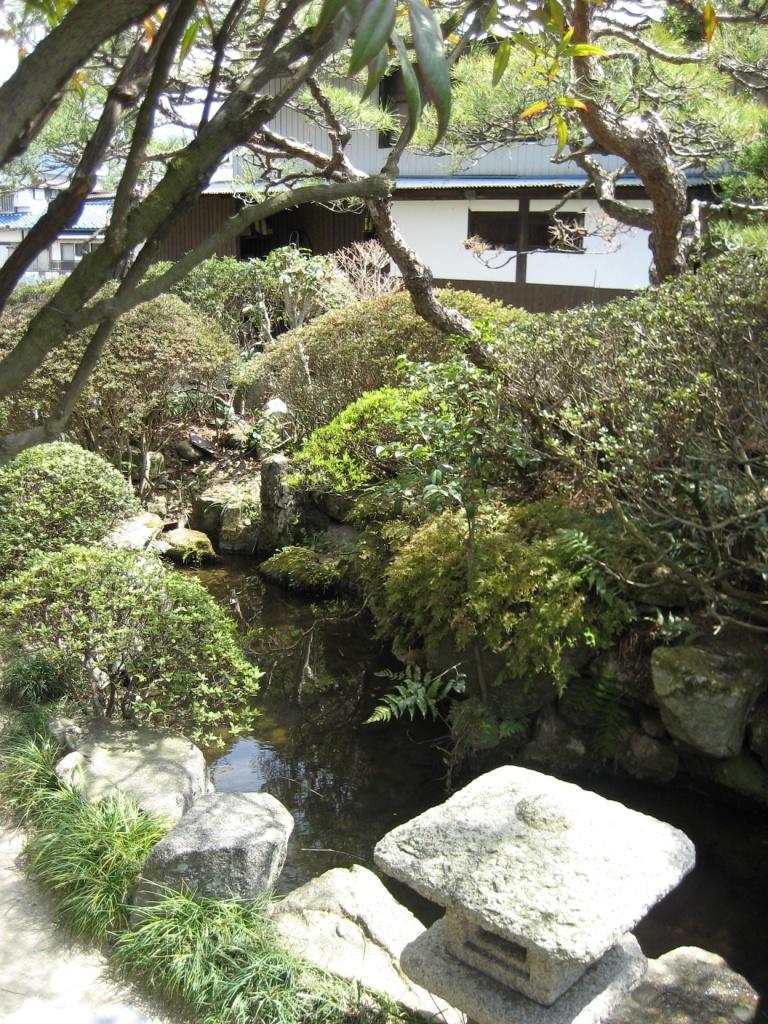Can you describe this image briefly? In this image we can see a building. We can also see some plants, water, rocks, the branches of a tree, a group of trees and the sky. 